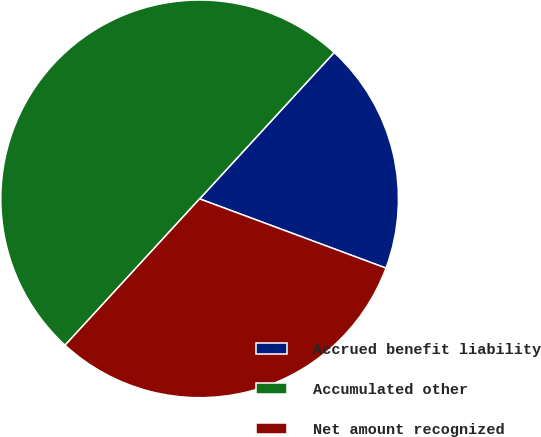Convert chart. <chart><loc_0><loc_0><loc_500><loc_500><pie_chart><fcel>Accrued benefit liability<fcel>Accumulated other<fcel>Net amount recognized<nl><fcel>18.83%<fcel>50.0%<fcel>31.17%<nl></chart> 